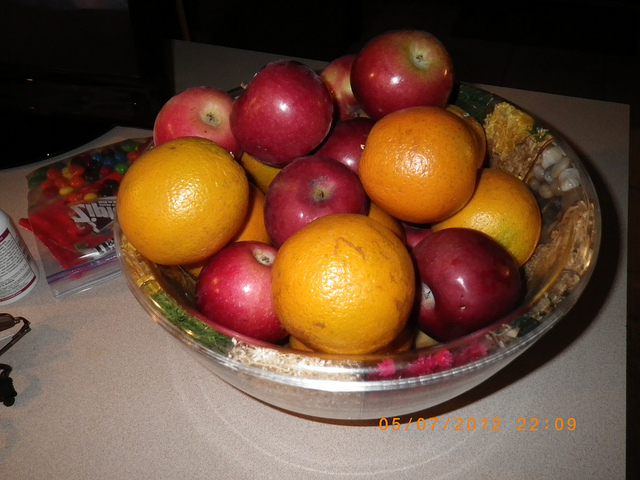Identify the text displayed in this image. 22:09 05/07/2017 